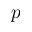<formula> <loc_0><loc_0><loc_500><loc_500>p</formula> 